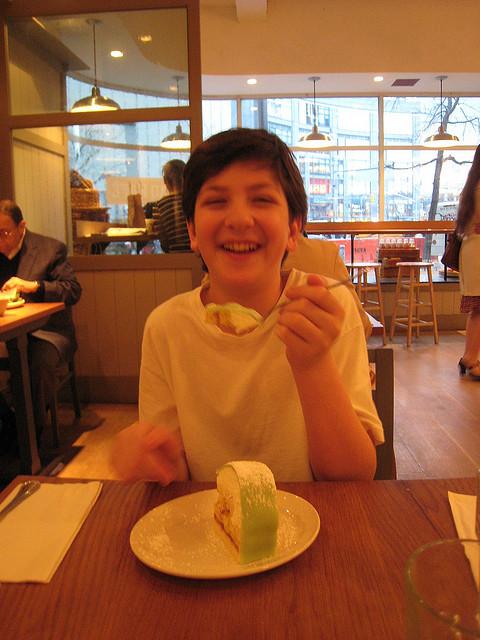What food is the child eating?
Write a very short answer. Cake. What is the child eating?
Keep it brief. Cake. What is next to the woman's ear?
Short answer required. Nothing. Which hand is the boy holding the utensil in?
Short answer required. Left. 